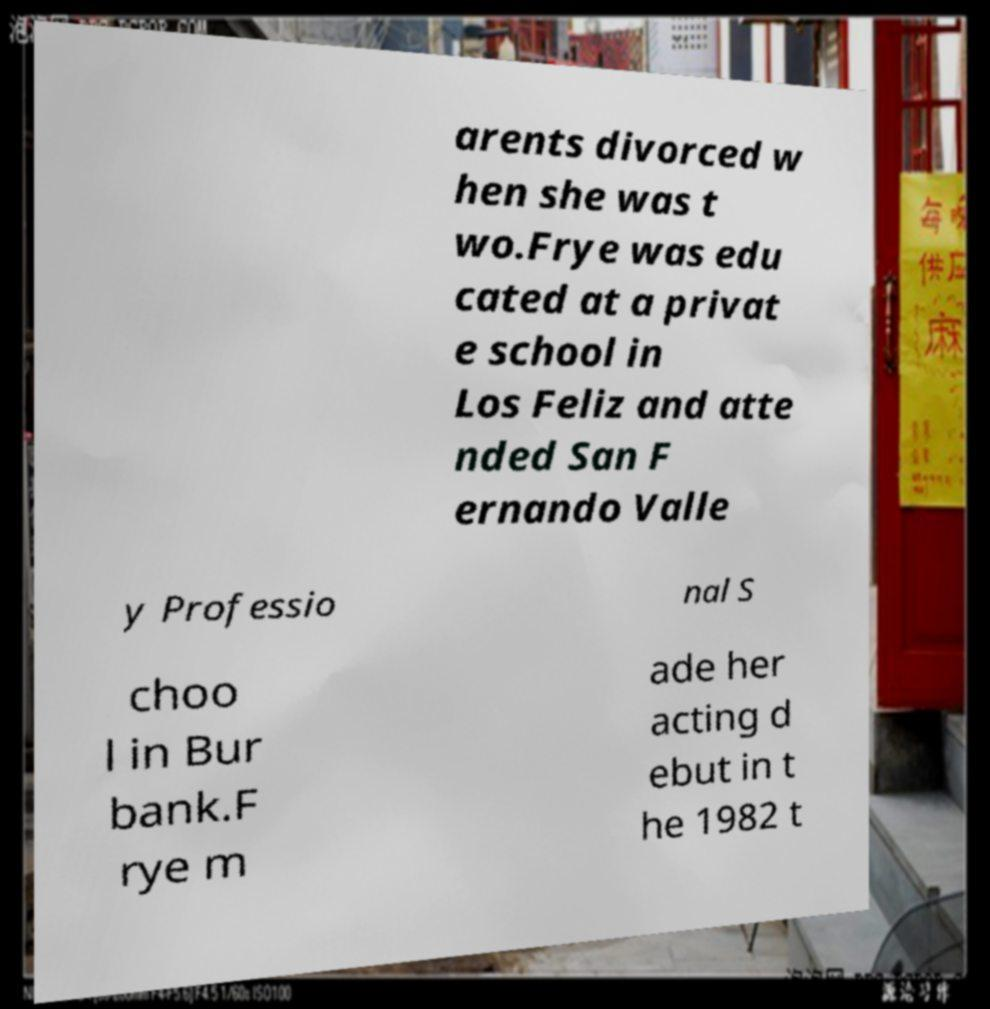I need the written content from this picture converted into text. Can you do that? arents divorced w hen she was t wo.Frye was edu cated at a privat e school in Los Feliz and atte nded San F ernando Valle y Professio nal S choo l in Bur bank.F rye m ade her acting d ebut in t he 1982 t 